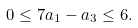Convert formula to latex. <formula><loc_0><loc_0><loc_500><loc_500>0 \leq 7 a _ { 1 } - a _ { 3 } \leq 6 .</formula> 